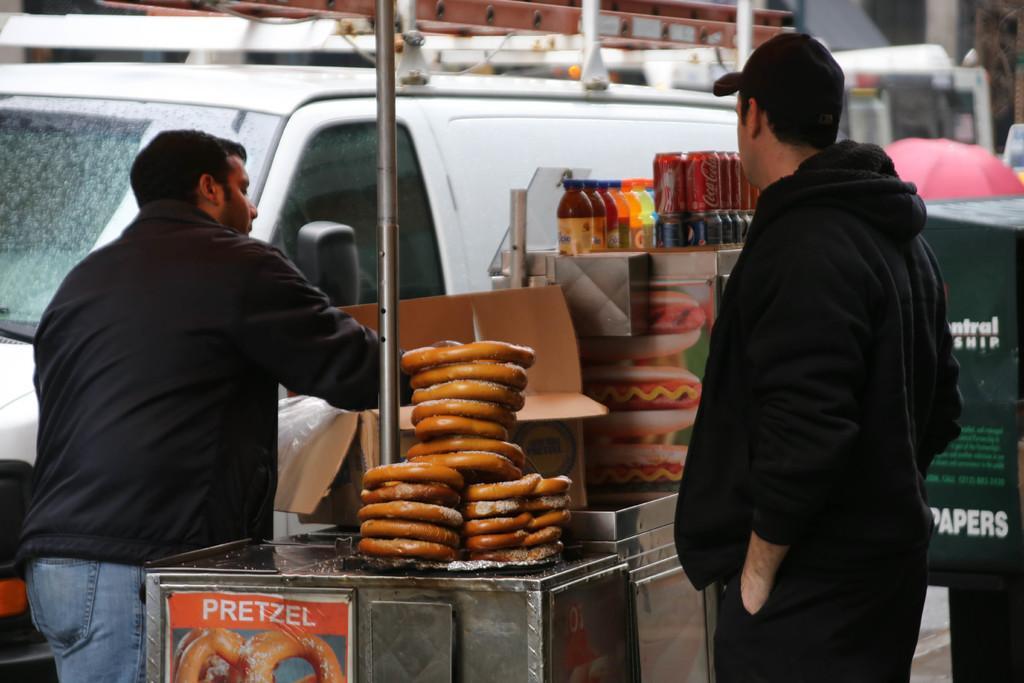Describe this image in one or two sentences. In this image I can see two person standing, the person at right wearing black color dress and the person at left wearing black jacket, blue jeans. In front I can see the food items, they are in brown color, I can also see few bottles and in front I can see the vehicle in white color. 